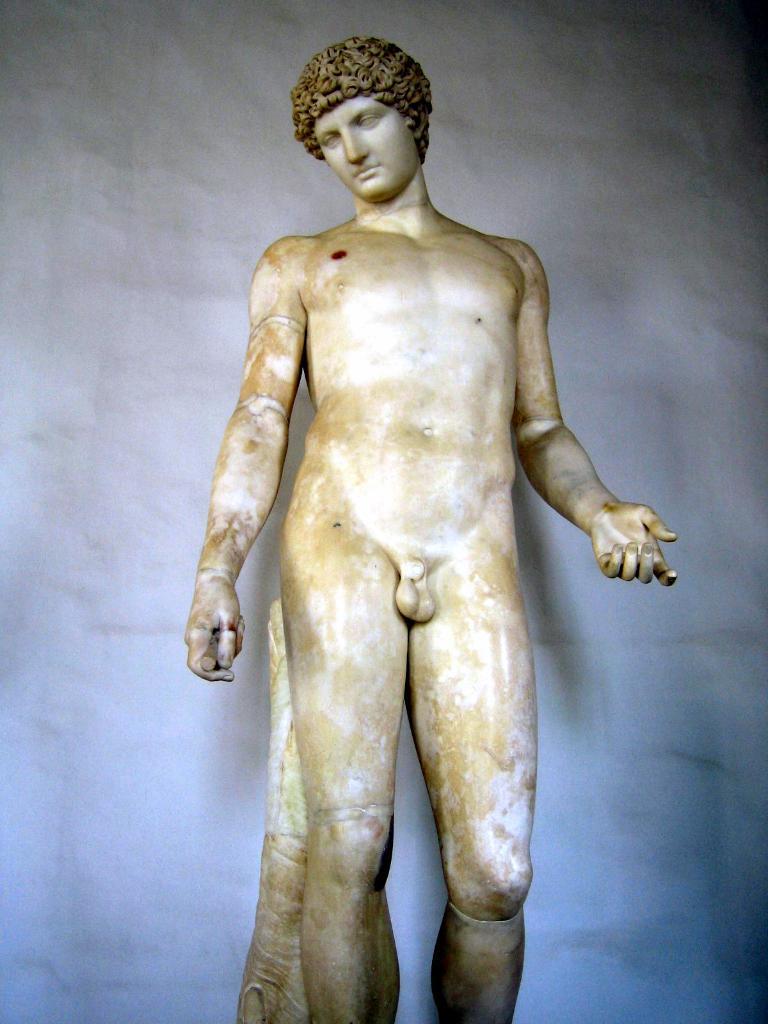Can you describe this image briefly? In this image I see a sculpture of a man and I see that it is of white and brown in color and in the background I see the white wall. 